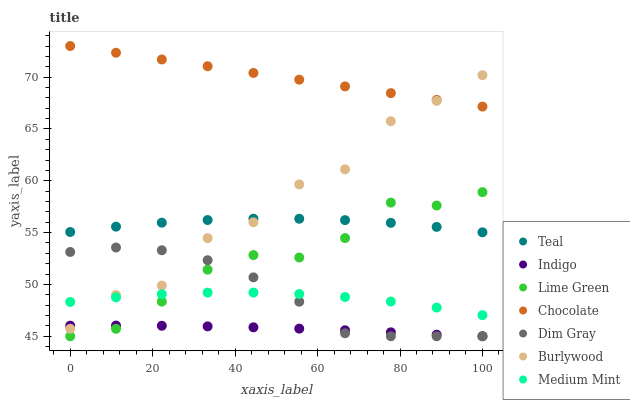Does Indigo have the minimum area under the curve?
Answer yes or no. Yes. Does Chocolate have the maximum area under the curve?
Answer yes or no. Yes. Does Dim Gray have the minimum area under the curve?
Answer yes or no. No. Does Dim Gray have the maximum area under the curve?
Answer yes or no. No. Is Chocolate the smoothest?
Answer yes or no. Yes. Is Burlywood the roughest?
Answer yes or no. Yes. Is Dim Gray the smoothest?
Answer yes or no. No. Is Dim Gray the roughest?
Answer yes or no. No. Does Dim Gray have the lowest value?
Answer yes or no. Yes. Does Burlywood have the lowest value?
Answer yes or no. No. Does Chocolate have the highest value?
Answer yes or no. Yes. Does Dim Gray have the highest value?
Answer yes or no. No. Is Lime Green less than Chocolate?
Answer yes or no. Yes. Is Chocolate greater than Lime Green?
Answer yes or no. Yes. Does Lime Green intersect Medium Mint?
Answer yes or no. Yes. Is Lime Green less than Medium Mint?
Answer yes or no. No. Is Lime Green greater than Medium Mint?
Answer yes or no. No. Does Lime Green intersect Chocolate?
Answer yes or no. No. 